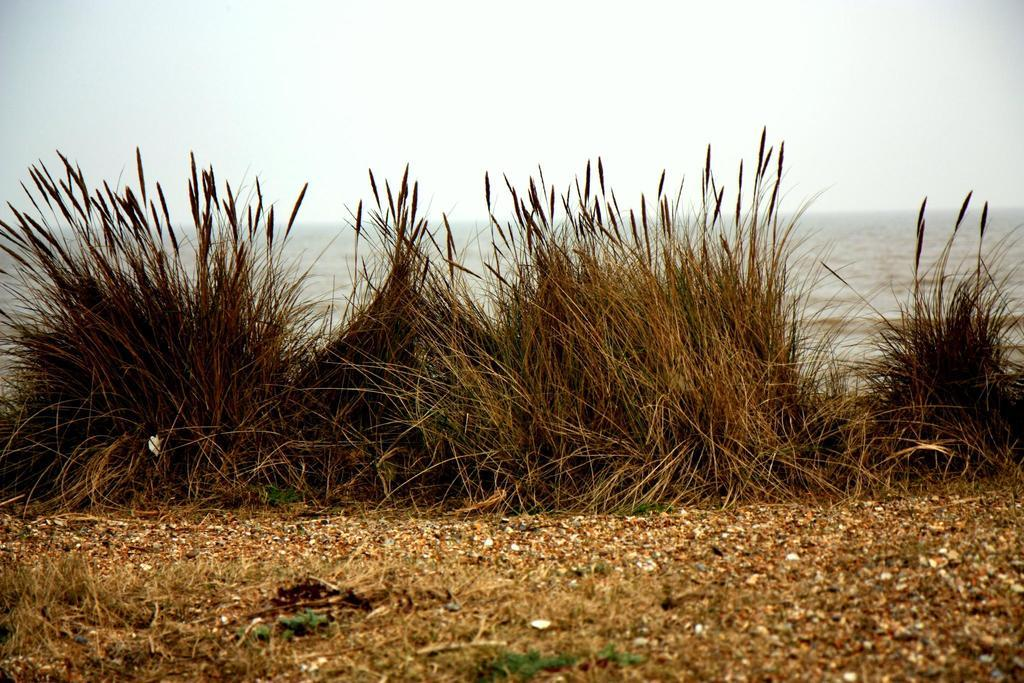What type of surface can be seen in the image? There is ground visible in the image. What type of vegetation is present in the image? There is grass in the image. What natural element is visible in the image? There is water visible in the image. What is visible in the background of the image? The sky is visible in the background of the image. Can you see any structures being built in the image? There is no mention of any structures being built in the image. Are there any fowl flying in the image? There is no mention of any fowl or flying creatures in the image. 